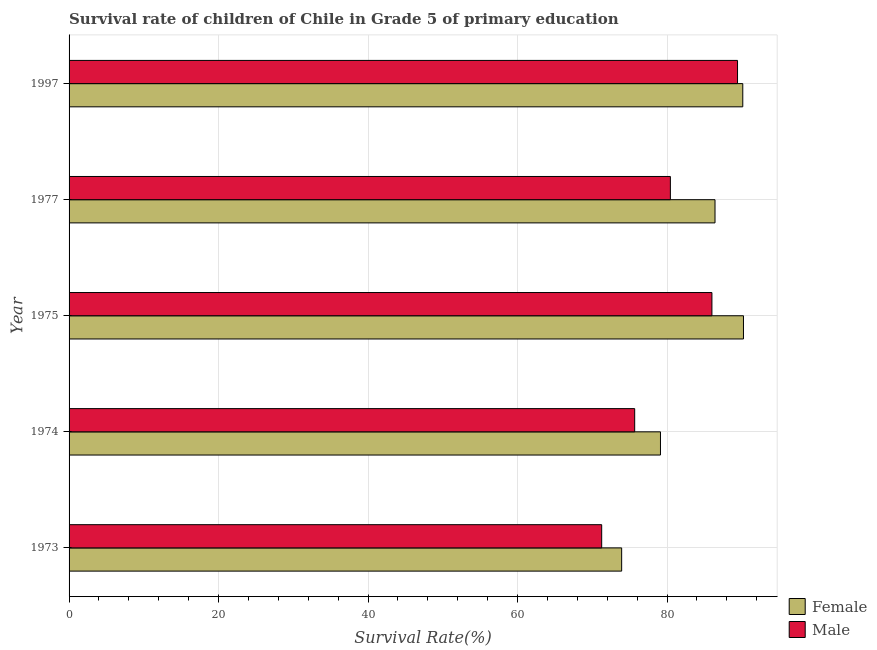How many groups of bars are there?
Give a very brief answer. 5. Are the number of bars per tick equal to the number of legend labels?
Offer a very short reply. Yes. What is the label of the 3rd group of bars from the top?
Offer a very short reply. 1975. What is the survival rate of male students in primary education in 1977?
Your answer should be compact. 80.45. Across all years, what is the maximum survival rate of male students in primary education?
Your response must be concise. 89.43. Across all years, what is the minimum survival rate of male students in primary education?
Provide a short and direct response. 71.26. In which year was the survival rate of female students in primary education maximum?
Make the answer very short. 1975. What is the total survival rate of male students in primary education in the graph?
Provide a succinct answer. 402.83. What is the difference between the survival rate of male students in primary education in 1975 and that in 1997?
Provide a succinct answer. -3.43. What is the difference between the survival rate of male students in primary education in 1975 and the survival rate of female students in primary education in 1974?
Ensure brevity in your answer.  6.88. What is the average survival rate of female students in primary education per year?
Keep it short and to the point. 83.97. In the year 1974, what is the difference between the survival rate of male students in primary education and survival rate of female students in primary education?
Offer a very short reply. -3.45. What is the ratio of the survival rate of male students in primary education in 1975 to that in 1977?
Ensure brevity in your answer.  1.07. What is the difference between the highest and the second highest survival rate of female students in primary education?
Give a very brief answer. 0.09. What is the difference between the highest and the lowest survival rate of male students in primary education?
Your answer should be very brief. 18.17. What does the 2nd bar from the bottom in 1973 represents?
Provide a succinct answer. Male. Are all the bars in the graph horizontal?
Offer a terse response. Yes. What is the difference between two consecutive major ticks on the X-axis?
Ensure brevity in your answer.  20. Are the values on the major ticks of X-axis written in scientific E-notation?
Make the answer very short. No. How many legend labels are there?
Provide a short and direct response. 2. What is the title of the graph?
Your answer should be very brief. Survival rate of children of Chile in Grade 5 of primary education. What is the label or title of the X-axis?
Your answer should be very brief. Survival Rate(%). What is the label or title of the Y-axis?
Provide a succinct answer. Year. What is the Survival Rate(%) in Female in 1973?
Your answer should be compact. 73.93. What is the Survival Rate(%) of Male in 1973?
Make the answer very short. 71.26. What is the Survival Rate(%) in Female in 1974?
Provide a succinct answer. 79.12. What is the Survival Rate(%) of Male in 1974?
Your answer should be compact. 75.67. What is the Survival Rate(%) in Female in 1975?
Ensure brevity in your answer.  90.23. What is the Survival Rate(%) in Male in 1975?
Offer a terse response. 86.01. What is the Survival Rate(%) in Female in 1977?
Offer a very short reply. 86.42. What is the Survival Rate(%) in Male in 1977?
Give a very brief answer. 80.45. What is the Survival Rate(%) of Female in 1997?
Your answer should be very brief. 90.14. What is the Survival Rate(%) of Male in 1997?
Your answer should be very brief. 89.43. Across all years, what is the maximum Survival Rate(%) in Female?
Keep it short and to the point. 90.23. Across all years, what is the maximum Survival Rate(%) in Male?
Provide a succinct answer. 89.43. Across all years, what is the minimum Survival Rate(%) in Female?
Give a very brief answer. 73.93. Across all years, what is the minimum Survival Rate(%) of Male?
Your answer should be compact. 71.26. What is the total Survival Rate(%) in Female in the graph?
Make the answer very short. 419.84. What is the total Survival Rate(%) in Male in the graph?
Your response must be concise. 402.83. What is the difference between the Survival Rate(%) of Female in 1973 and that in 1974?
Ensure brevity in your answer.  -5.19. What is the difference between the Survival Rate(%) of Male in 1973 and that in 1974?
Provide a short and direct response. -4.42. What is the difference between the Survival Rate(%) of Female in 1973 and that in 1975?
Offer a very short reply. -16.3. What is the difference between the Survival Rate(%) in Male in 1973 and that in 1975?
Give a very brief answer. -14.75. What is the difference between the Survival Rate(%) in Female in 1973 and that in 1977?
Your response must be concise. -12.49. What is the difference between the Survival Rate(%) in Male in 1973 and that in 1977?
Give a very brief answer. -9.19. What is the difference between the Survival Rate(%) of Female in 1973 and that in 1997?
Your answer should be compact. -16.21. What is the difference between the Survival Rate(%) of Male in 1973 and that in 1997?
Offer a terse response. -18.18. What is the difference between the Survival Rate(%) of Female in 1974 and that in 1975?
Your response must be concise. -11.11. What is the difference between the Survival Rate(%) of Male in 1974 and that in 1975?
Offer a terse response. -10.33. What is the difference between the Survival Rate(%) in Female in 1974 and that in 1977?
Offer a very short reply. -7.3. What is the difference between the Survival Rate(%) in Male in 1974 and that in 1977?
Make the answer very short. -4.77. What is the difference between the Survival Rate(%) of Female in 1974 and that in 1997?
Provide a short and direct response. -11.01. What is the difference between the Survival Rate(%) in Male in 1974 and that in 1997?
Provide a short and direct response. -13.76. What is the difference between the Survival Rate(%) in Female in 1975 and that in 1977?
Your answer should be compact. 3.81. What is the difference between the Survival Rate(%) of Male in 1975 and that in 1977?
Offer a terse response. 5.56. What is the difference between the Survival Rate(%) in Female in 1975 and that in 1997?
Provide a succinct answer. 0.09. What is the difference between the Survival Rate(%) of Male in 1975 and that in 1997?
Keep it short and to the point. -3.43. What is the difference between the Survival Rate(%) in Female in 1977 and that in 1997?
Give a very brief answer. -3.72. What is the difference between the Survival Rate(%) in Male in 1977 and that in 1997?
Offer a very short reply. -8.98. What is the difference between the Survival Rate(%) of Female in 1973 and the Survival Rate(%) of Male in 1974?
Give a very brief answer. -1.74. What is the difference between the Survival Rate(%) of Female in 1973 and the Survival Rate(%) of Male in 1975?
Your response must be concise. -12.08. What is the difference between the Survival Rate(%) in Female in 1973 and the Survival Rate(%) in Male in 1977?
Your answer should be compact. -6.52. What is the difference between the Survival Rate(%) in Female in 1973 and the Survival Rate(%) in Male in 1997?
Offer a terse response. -15.5. What is the difference between the Survival Rate(%) in Female in 1974 and the Survival Rate(%) in Male in 1975?
Give a very brief answer. -6.88. What is the difference between the Survival Rate(%) in Female in 1974 and the Survival Rate(%) in Male in 1977?
Give a very brief answer. -1.33. What is the difference between the Survival Rate(%) in Female in 1974 and the Survival Rate(%) in Male in 1997?
Give a very brief answer. -10.31. What is the difference between the Survival Rate(%) in Female in 1975 and the Survival Rate(%) in Male in 1977?
Offer a very short reply. 9.78. What is the difference between the Survival Rate(%) of Female in 1975 and the Survival Rate(%) of Male in 1997?
Offer a terse response. 0.79. What is the difference between the Survival Rate(%) in Female in 1977 and the Survival Rate(%) in Male in 1997?
Make the answer very short. -3.01. What is the average Survival Rate(%) in Female per year?
Give a very brief answer. 83.97. What is the average Survival Rate(%) in Male per year?
Your response must be concise. 80.57. In the year 1973, what is the difference between the Survival Rate(%) of Female and Survival Rate(%) of Male?
Offer a terse response. 2.67. In the year 1974, what is the difference between the Survival Rate(%) in Female and Survival Rate(%) in Male?
Give a very brief answer. 3.45. In the year 1975, what is the difference between the Survival Rate(%) in Female and Survival Rate(%) in Male?
Your response must be concise. 4.22. In the year 1977, what is the difference between the Survival Rate(%) in Female and Survival Rate(%) in Male?
Offer a very short reply. 5.97. In the year 1997, what is the difference between the Survival Rate(%) of Female and Survival Rate(%) of Male?
Make the answer very short. 0.7. What is the ratio of the Survival Rate(%) of Female in 1973 to that in 1974?
Provide a succinct answer. 0.93. What is the ratio of the Survival Rate(%) in Male in 1973 to that in 1974?
Your answer should be compact. 0.94. What is the ratio of the Survival Rate(%) in Female in 1973 to that in 1975?
Keep it short and to the point. 0.82. What is the ratio of the Survival Rate(%) in Male in 1973 to that in 1975?
Your answer should be very brief. 0.83. What is the ratio of the Survival Rate(%) of Female in 1973 to that in 1977?
Your answer should be compact. 0.86. What is the ratio of the Survival Rate(%) in Male in 1973 to that in 1977?
Your answer should be compact. 0.89. What is the ratio of the Survival Rate(%) in Female in 1973 to that in 1997?
Give a very brief answer. 0.82. What is the ratio of the Survival Rate(%) of Male in 1973 to that in 1997?
Offer a very short reply. 0.8. What is the ratio of the Survival Rate(%) in Female in 1974 to that in 1975?
Offer a very short reply. 0.88. What is the ratio of the Survival Rate(%) in Male in 1974 to that in 1975?
Keep it short and to the point. 0.88. What is the ratio of the Survival Rate(%) in Female in 1974 to that in 1977?
Offer a very short reply. 0.92. What is the ratio of the Survival Rate(%) of Male in 1974 to that in 1977?
Your answer should be compact. 0.94. What is the ratio of the Survival Rate(%) of Female in 1974 to that in 1997?
Your response must be concise. 0.88. What is the ratio of the Survival Rate(%) in Male in 1974 to that in 1997?
Provide a succinct answer. 0.85. What is the ratio of the Survival Rate(%) of Female in 1975 to that in 1977?
Keep it short and to the point. 1.04. What is the ratio of the Survival Rate(%) of Male in 1975 to that in 1977?
Your answer should be very brief. 1.07. What is the ratio of the Survival Rate(%) in Female in 1975 to that in 1997?
Your answer should be very brief. 1. What is the ratio of the Survival Rate(%) of Male in 1975 to that in 1997?
Ensure brevity in your answer.  0.96. What is the ratio of the Survival Rate(%) in Female in 1977 to that in 1997?
Give a very brief answer. 0.96. What is the ratio of the Survival Rate(%) in Male in 1977 to that in 1997?
Give a very brief answer. 0.9. What is the difference between the highest and the second highest Survival Rate(%) in Female?
Offer a terse response. 0.09. What is the difference between the highest and the second highest Survival Rate(%) of Male?
Provide a short and direct response. 3.43. What is the difference between the highest and the lowest Survival Rate(%) in Female?
Make the answer very short. 16.3. What is the difference between the highest and the lowest Survival Rate(%) in Male?
Provide a short and direct response. 18.18. 